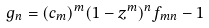Convert formula to latex. <formula><loc_0><loc_0><loc_500><loc_500>g _ { n } = ( c _ { m } ) ^ { m } ( 1 - z ^ { m } ) ^ { n } f _ { m n } - 1</formula> 